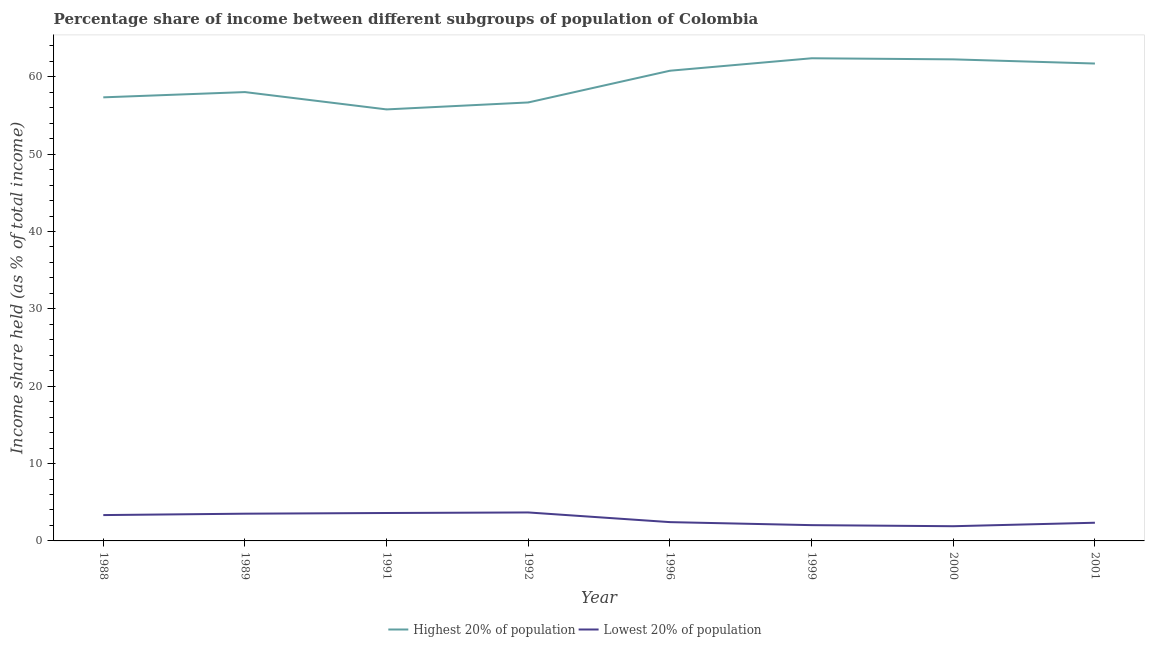How many different coloured lines are there?
Your answer should be compact. 2. Does the line corresponding to income share held by highest 20% of the population intersect with the line corresponding to income share held by lowest 20% of the population?
Ensure brevity in your answer.  No. What is the income share held by lowest 20% of the population in 1992?
Offer a very short reply. 3.68. Across all years, what is the maximum income share held by lowest 20% of the population?
Ensure brevity in your answer.  3.68. Across all years, what is the minimum income share held by highest 20% of the population?
Keep it short and to the point. 55.78. In which year was the income share held by highest 20% of the population minimum?
Provide a short and direct response. 1991. What is the total income share held by lowest 20% of the population in the graph?
Your answer should be very brief. 22.87. What is the difference between the income share held by highest 20% of the population in 1992 and that in 2001?
Your answer should be very brief. -5.03. What is the difference between the income share held by lowest 20% of the population in 2001 and the income share held by highest 20% of the population in 2000?
Offer a terse response. -59.9. What is the average income share held by highest 20% of the population per year?
Ensure brevity in your answer.  59.37. In the year 1992, what is the difference between the income share held by lowest 20% of the population and income share held by highest 20% of the population?
Make the answer very short. -53. In how many years, is the income share held by lowest 20% of the population greater than 18 %?
Your response must be concise. 0. What is the ratio of the income share held by highest 20% of the population in 1988 to that in 2000?
Your response must be concise. 0.92. Is the income share held by lowest 20% of the population in 1991 less than that in 2001?
Keep it short and to the point. No. Is the difference between the income share held by lowest 20% of the population in 1992 and 1996 greater than the difference between the income share held by highest 20% of the population in 1992 and 1996?
Your response must be concise. Yes. What is the difference between the highest and the second highest income share held by highest 20% of the population?
Your answer should be very brief. 0.14. What is the difference between the highest and the lowest income share held by lowest 20% of the population?
Ensure brevity in your answer.  1.78. In how many years, is the income share held by lowest 20% of the population greater than the average income share held by lowest 20% of the population taken over all years?
Make the answer very short. 4. Is the sum of the income share held by highest 20% of the population in 1989 and 1992 greater than the maximum income share held by lowest 20% of the population across all years?
Your answer should be very brief. Yes. How many lines are there?
Your response must be concise. 2. Are the values on the major ticks of Y-axis written in scientific E-notation?
Make the answer very short. No. Does the graph contain grids?
Your response must be concise. No. How many legend labels are there?
Give a very brief answer. 2. How are the legend labels stacked?
Ensure brevity in your answer.  Horizontal. What is the title of the graph?
Give a very brief answer. Percentage share of income between different subgroups of population of Colombia. Does "Investment in Telecom" appear as one of the legend labels in the graph?
Offer a terse response. No. What is the label or title of the X-axis?
Make the answer very short. Year. What is the label or title of the Y-axis?
Keep it short and to the point. Income share held (as % of total income). What is the Income share held (as % of total income) in Highest 20% of population in 1988?
Your answer should be very brief. 57.34. What is the Income share held (as % of total income) of Lowest 20% of population in 1988?
Offer a very short reply. 3.34. What is the Income share held (as % of total income) in Highest 20% of population in 1989?
Give a very brief answer. 58.02. What is the Income share held (as % of total income) in Lowest 20% of population in 1989?
Give a very brief answer. 3.52. What is the Income share held (as % of total income) in Highest 20% of population in 1991?
Offer a very short reply. 55.78. What is the Income share held (as % of total income) of Lowest 20% of population in 1991?
Your answer should be very brief. 3.61. What is the Income share held (as % of total income) in Highest 20% of population in 1992?
Your answer should be compact. 56.68. What is the Income share held (as % of total income) in Lowest 20% of population in 1992?
Your response must be concise. 3.68. What is the Income share held (as % of total income) of Highest 20% of population in 1996?
Offer a terse response. 60.78. What is the Income share held (as % of total income) in Lowest 20% of population in 1996?
Offer a very short reply. 2.43. What is the Income share held (as % of total income) in Highest 20% of population in 1999?
Your answer should be compact. 62.39. What is the Income share held (as % of total income) of Lowest 20% of population in 1999?
Your response must be concise. 2.04. What is the Income share held (as % of total income) in Highest 20% of population in 2000?
Provide a succinct answer. 62.25. What is the Income share held (as % of total income) in Highest 20% of population in 2001?
Your response must be concise. 61.71. What is the Income share held (as % of total income) in Lowest 20% of population in 2001?
Your response must be concise. 2.35. Across all years, what is the maximum Income share held (as % of total income) in Highest 20% of population?
Give a very brief answer. 62.39. Across all years, what is the maximum Income share held (as % of total income) of Lowest 20% of population?
Provide a succinct answer. 3.68. Across all years, what is the minimum Income share held (as % of total income) in Highest 20% of population?
Ensure brevity in your answer.  55.78. Across all years, what is the minimum Income share held (as % of total income) in Lowest 20% of population?
Offer a terse response. 1.9. What is the total Income share held (as % of total income) of Highest 20% of population in the graph?
Provide a succinct answer. 474.95. What is the total Income share held (as % of total income) of Lowest 20% of population in the graph?
Keep it short and to the point. 22.87. What is the difference between the Income share held (as % of total income) of Highest 20% of population in 1988 and that in 1989?
Make the answer very short. -0.68. What is the difference between the Income share held (as % of total income) in Lowest 20% of population in 1988 and that in 1989?
Offer a terse response. -0.18. What is the difference between the Income share held (as % of total income) of Highest 20% of population in 1988 and that in 1991?
Your response must be concise. 1.56. What is the difference between the Income share held (as % of total income) in Lowest 20% of population in 1988 and that in 1991?
Make the answer very short. -0.27. What is the difference between the Income share held (as % of total income) in Highest 20% of population in 1988 and that in 1992?
Make the answer very short. 0.66. What is the difference between the Income share held (as % of total income) of Lowest 20% of population in 1988 and that in 1992?
Provide a short and direct response. -0.34. What is the difference between the Income share held (as % of total income) of Highest 20% of population in 1988 and that in 1996?
Provide a short and direct response. -3.44. What is the difference between the Income share held (as % of total income) of Lowest 20% of population in 1988 and that in 1996?
Your answer should be very brief. 0.91. What is the difference between the Income share held (as % of total income) in Highest 20% of population in 1988 and that in 1999?
Give a very brief answer. -5.05. What is the difference between the Income share held (as % of total income) in Lowest 20% of population in 1988 and that in 1999?
Keep it short and to the point. 1.3. What is the difference between the Income share held (as % of total income) in Highest 20% of population in 1988 and that in 2000?
Offer a terse response. -4.91. What is the difference between the Income share held (as % of total income) of Lowest 20% of population in 1988 and that in 2000?
Your response must be concise. 1.44. What is the difference between the Income share held (as % of total income) of Highest 20% of population in 1988 and that in 2001?
Provide a succinct answer. -4.37. What is the difference between the Income share held (as % of total income) in Lowest 20% of population in 1988 and that in 2001?
Offer a terse response. 0.99. What is the difference between the Income share held (as % of total income) in Highest 20% of population in 1989 and that in 1991?
Offer a terse response. 2.24. What is the difference between the Income share held (as % of total income) in Lowest 20% of population in 1989 and that in 1991?
Your response must be concise. -0.09. What is the difference between the Income share held (as % of total income) of Highest 20% of population in 1989 and that in 1992?
Ensure brevity in your answer.  1.34. What is the difference between the Income share held (as % of total income) in Lowest 20% of population in 1989 and that in 1992?
Your answer should be compact. -0.16. What is the difference between the Income share held (as % of total income) of Highest 20% of population in 1989 and that in 1996?
Provide a short and direct response. -2.76. What is the difference between the Income share held (as % of total income) of Lowest 20% of population in 1989 and that in 1996?
Your answer should be compact. 1.09. What is the difference between the Income share held (as % of total income) in Highest 20% of population in 1989 and that in 1999?
Your answer should be compact. -4.37. What is the difference between the Income share held (as % of total income) in Lowest 20% of population in 1989 and that in 1999?
Provide a succinct answer. 1.48. What is the difference between the Income share held (as % of total income) of Highest 20% of population in 1989 and that in 2000?
Ensure brevity in your answer.  -4.23. What is the difference between the Income share held (as % of total income) of Lowest 20% of population in 1989 and that in 2000?
Ensure brevity in your answer.  1.62. What is the difference between the Income share held (as % of total income) in Highest 20% of population in 1989 and that in 2001?
Offer a very short reply. -3.69. What is the difference between the Income share held (as % of total income) of Lowest 20% of population in 1989 and that in 2001?
Provide a succinct answer. 1.17. What is the difference between the Income share held (as % of total income) of Lowest 20% of population in 1991 and that in 1992?
Give a very brief answer. -0.07. What is the difference between the Income share held (as % of total income) in Lowest 20% of population in 1991 and that in 1996?
Ensure brevity in your answer.  1.18. What is the difference between the Income share held (as % of total income) of Highest 20% of population in 1991 and that in 1999?
Offer a very short reply. -6.61. What is the difference between the Income share held (as % of total income) of Lowest 20% of population in 1991 and that in 1999?
Your answer should be very brief. 1.57. What is the difference between the Income share held (as % of total income) in Highest 20% of population in 1991 and that in 2000?
Make the answer very short. -6.47. What is the difference between the Income share held (as % of total income) of Lowest 20% of population in 1991 and that in 2000?
Your answer should be compact. 1.71. What is the difference between the Income share held (as % of total income) in Highest 20% of population in 1991 and that in 2001?
Your answer should be compact. -5.93. What is the difference between the Income share held (as % of total income) of Lowest 20% of population in 1991 and that in 2001?
Your answer should be very brief. 1.26. What is the difference between the Income share held (as % of total income) in Highest 20% of population in 1992 and that in 1996?
Ensure brevity in your answer.  -4.1. What is the difference between the Income share held (as % of total income) in Highest 20% of population in 1992 and that in 1999?
Your answer should be compact. -5.71. What is the difference between the Income share held (as % of total income) of Lowest 20% of population in 1992 and that in 1999?
Make the answer very short. 1.64. What is the difference between the Income share held (as % of total income) in Highest 20% of population in 1992 and that in 2000?
Make the answer very short. -5.57. What is the difference between the Income share held (as % of total income) of Lowest 20% of population in 1992 and that in 2000?
Your answer should be compact. 1.78. What is the difference between the Income share held (as % of total income) of Highest 20% of population in 1992 and that in 2001?
Ensure brevity in your answer.  -5.03. What is the difference between the Income share held (as % of total income) of Lowest 20% of population in 1992 and that in 2001?
Provide a succinct answer. 1.33. What is the difference between the Income share held (as % of total income) of Highest 20% of population in 1996 and that in 1999?
Give a very brief answer. -1.61. What is the difference between the Income share held (as % of total income) of Lowest 20% of population in 1996 and that in 1999?
Your answer should be very brief. 0.39. What is the difference between the Income share held (as % of total income) of Highest 20% of population in 1996 and that in 2000?
Ensure brevity in your answer.  -1.47. What is the difference between the Income share held (as % of total income) in Lowest 20% of population in 1996 and that in 2000?
Keep it short and to the point. 0.53. What is the difference between the Income share held (as % of total income) of Highest 20% of population in 1996 and that in 2001?
Offer a terse response. -0.93. What is the difference between the Income share held (as % of total income) in Highest 20% of population in 1999 and that in 2000?
Ensure brevity in your answer.  0.14. What is the difference between the Income share held (as % of total income) of Lowest 20% of population in 1999 and that in 2000?
Give a very brief answer. 0.14. What is the difference between the Income share held (as % of total income) in Highest 20% of population in 1999 and that in 2001?
Your answer should be very brief. 0.68. What is the difference between the Income share held (as % of total income) of Lowest 20% of population in 1999 and that in 2001?
Your response must be concise. -0.31. What is the difference between the Income share held (as % of total income) in Highest 20% of population in 2000 and that in 2001?
Give a very brief answer. 0.54. What is the difference between the Income share held (as % of total income) of Lowest 20% of population in 2000 and that in 2001?
Your response must be concise. -0.45. What is the difference between the Income share held (as % of total income) of Highest 20% of population in 1988 and the Income share held (as % of total income) of Lowest 20% of population in 1989?
Ensure brevity in your answer.  53.82. What is the difference between the Income share held (as % of total income) of Highest 20% of population in 1988 and the Income share held (as % of total income) of Lowest 20% of population in 1991?
Offer a very short reply. 53.73. What is the difference between the Income share held (as % of total income) of Highest 20% of population in 1988 and the Income share held (as % of total income) of Lowest 20% of population in 1992?
Make the answer very short. 53.66. What is the difference between the Income share held (as % of total income) in Highest 20% of population in 1988 and the Income share held (as % of total income) in Lowest 20% of population in 1996?
Keep it short and to the point. 54.91. What is the difference between the Income share held (as % of total income) of Highest 20% of population in 1988 and the Income share held (as % of total income) of Lowest 20% of population in 1999?
Provide a succinct answer. 55.3. What is the difference between the Income share held (as % of total income) of Highest 20% of population in 1988 and the Income share held (as % of total income) of Lowest 20% of population in 2000?
Your response must be concise. 55.44. What is the difference between the Income share held (as % of total income) in Highest 20% of population in 1988 and the Income share held (as % of total income) in Lowest 20% of population in 2001?
Provide a short and direct response. 54.99. What is the difference between the Income share held (as % of total income) in Highest 20% of population in 1989 and the Income share held (as % of total income) in Lowest 20% of population in 1991?
Offer a very short reply. 54.41. What is the difference between the Income share held (as % of total income) in Highest 20% of population in 1989 and the Income share held (as % of total income) in Lowest 20% of population in 1992?
Your response must be concise. 54.34. What is the difference between the Income share held (as % of total income) in Highest 20% of population in 1989 and the Income share held (as % of total income) in Lowest 20% of population in 1996?
Your answer should be very brief. 55.59. What is the difference between the Income share held (as % of total income) of Highest 20% of population in 1989 and the Income share held (as % of total income) of Lowest 20% of population in 1999?
Your response must be concise. 55.98. What is the difference between the Income share held (as % of total income) of Highest 20% of population in 1989 and the Income share held (as % of total income) of Lowest 20% of population in 2000?
Ensure brevity in your answer.  56.12. What is the difference between the Income share held (as % of total income) in Highest 20% of population in 1989 and the Income share held (as % of total income) in Lowest 20% of population in 2001?
Your answer should be compact. 55.67. What is the difference between the Income share held (as % of total income) of Highest 20% of population in 1991 and the Income share held (as % of total income) of Lowest 20% of population in 1992?
Give a very brief answer. 52.1. What is the difference between the Income share held (as % of total income) of Highest 20% of population in 1991 and the Income share held (as % of total income) of Lowest 20% of population in 1996?
Give a very brief answer. 53.35. What is the difference between the Income share held (as % of total income) in Highest 20% of population in 1991 and the Income share held (as % of total income) in Lowest 20% of population in 1999?
Keep it short and to the point. 53.74. What is the difference between the Income share held (as % of total income) of Highest 20% of population in 1991 and the Income share held (as % of total income) of Lowest 20% of population in 2000?
Your answer should be compact. 53.88. What is the difference between the Income share held (as % of total income) in Highest 20% of population in 1991 and the Income share held (as % of total income) in Lowest 20% of population in 2001?
Provide a succinct answer. 53.43. What is the difference between the Income share held (as % of total income) of Highest 20% of population in 1992 and the Income share held (as % of total income) of Lowest 20% of population in 1996?
Your answer should be compact. 54.25. What is the difference between the Income share held (as % of total income) of Highest 20% of population in 1992 and the Income share held (as % of total income) of Lowest 20% of population in 1999?
Your response must be concise. 54.64. What is the difference between the Income share held (as % of total income) of Highest 20% of population in 1992 and the Income share held (as % of total income) of Lowest 20% of population in 2000?
Your response must be concise. 54.78. What is the difference between the Income share held (as % of total income) in Highest 20% of population in 1992 and the Income share held (as % of total income) in Lowest 20% of population in 2001?
Your answer should be very brief. 54.33. What is the difference between the Income share held (as % of total income) in Highest 20% of population in 1996 and the Income share held (as % of total income) in Lowest 20% of population in 1999?
Provide a short and direct response. 58.74. What is the difference between the Income share held (as % of total income) in Highest 20% of population in 1996 and the Income share held (as % of total income) in Lowest 20% of population in 2000?
Give a very brief answer. 58.88. What is the difference between the Income share held (as % of total income) of Highest 20% of population in 1996 and the Income share held (as % of total income) of Lowest 20% of population in 2001?
Provide a succinct answer. 58.43. What is the difference between the Income share held (as % of total income) of Highest 20% of population in 1999 and the Income share held (as % of total income) of Lowest 20% of population in 2000?
Offer a terse response. 60.49. What is the difference between the Income share held (as % of total income) in Highest 20% of population in 1999 and the Income share held (as % of total income) in Lowest 20% of population in 2001?
Offer a very short reply. 60.04. What is the difference between the Income share held (as % of total income) in Highest 20% of population in 2000 and the Income share held (as % of total income) in Lowest 20% of population in 2001?
Keep it short and to the point. 59.9. What is the average Income share held (as % of total income) of Highest 20% of population per year?
Your response must be concise. 59.37. What is the average Income share held (as % of total income) of Lowest 20% of population per year?
Ensure brevity in your answer.  2.86. In the year 1989, what is the difference between the Income share held (as % of total income) in Highest 20% of population and Income share held (as % of total income) in Lowest 20% of population?
Give a very brief answer. 54.5. In the year 1991, what is the difference between the Income share held (as % of total income) in Highest 20% of population and Income share held (as % of total income) in Lowest 20% of population?
Give a very brief answer. 52.17. In the year 1992, what is the difference between the Income share held (as % of total income) in Highest 20% of population and Income share held (as % of total income) in Lowest 20% of population?
Provide a short and direct response. 53. In the year 1996, what is the difference between the Income share held (as % of total income) in Highest 20% of population and Income share held (as % of total income) in Lowest 20% of population?
Your response must be concise. 58.35. In the year 1999, what is the difference between the Income share held (as % of total income) of Highest 20% of population and Income share held (as % of total income) of Lowest 20% of population?
Your answer should be compact. 60.35. In the year 2000, what is the difference between the Income share held (as % of total income) of Highest 20% of population and Income share held (as % of total income) of Lowest 20% of population?
Your answer should be compact. 60.35. In the year 2001, what is the difference between the Income share held (as % of total income) in Highest 20% of population and Income share held (as % of total income) in Lowest 20% of population?
Provide a succinct answer. 59.36. What is the ratio of the Income share held (as % of total income) of Highest 20% of population in 1988 to that in 1989?
Your answer should be very brief. 0.99. What is the ratio of the Income share held (as % of total income) in Lowest 20% of population in 1988 to that in 1989?
Make the answer very short. 0.95. What is the ratio of the Income share held (as % of total income) of Highest 20% of population in 1988 to that in 1991?
Provide a succinct answer. 1.03. What is the ratio of the Income share held (as % of total income) in Lowest 20% of population in 1988 to that in 1991?
Your answer should be compact. 0.93. What is the ratio of the Income share held (as % of total income) in Highest 20% of population in 1988 to that in 1992?
Offer a very short reply. 1.01. What is the ratio of the Income share held (as % of total income) in Lowest 20% of population in 1988 to that in 1992?
Your response must be concise. 0.91. What is the ratio of the Income share held (as % of total income) of Highest 20% of population in 1988 to that in 1996?
Offer a terse response. 0.94. What is the ratio of the Income share held (as % of total income) of Lowest 20% of population in 1988 to that in 1996?
Give a very brief answer. 1.37. What is the ratio of the Income share held (as % of total income) of Highest 20% of population in 1988 to that in 1999?
Your answer should be compact. 0.92. What is the ratio of the Income share held (as % of total income) of Lowest 20% of population in 1988 to that in 1999?
Give a very brief answer. 1.64. What is the ratio of the Income share held (as % of total income) in Highest 20% of population in 1988 to that in 2000?
Keep it short and to the point. 0.92. What is the ratio of the Income share held (as % of total income) in Lowest 20% of population in 1988 to that in 2000?
Ensure brevity in your answer.  1.76. What is the ratio of the Income share held (as % of total income) of Highest 20% of population in 1988 to that in 2001?
Offer a terse response. 0.93. What is the ratio of the Income share held (as % of total income) in Lowest 20% of population in 1988 to that in 2001?
Make the answer very short. 1.42. What is the ratio of the Income share held (as % of total income) in Highest 20% of population in 1989 to that in 1991?
Make the answer very short. 1.04. What is the ratio of the Income share held (as % of total income) of Lowest 20% of population in 1989 to that in 1991?
Give a very brief answer. 0.98. What is the ratio of the Income share held (as % of total income) in Highest 20% of population in 1989 to that in 1992?
Your answer should be compact. 1.02. What is the ratio of the Income share held (as % of total income) in Lowest 20% of population in 1989 to that in 1992?
Offer a terse response. 0.96. What is the ratio of the Income share held (as % of total income) of Highest 20% of population in 1989 to that in 1996?
Ensure brevity in your answer.  0.95. What is the ratio of the Income share held (as % of total income) of Lowest 20% of population in 1989 to that in 1996?
Give a very brief answer. 1.45. What is the ratio of the Income share held (as % of total income) of Highest 20% of population in 1989 to that in 1999?
Provide a succinct answer. 0.93. What is the ratio of the Income share held (as % of total income) in Lowest 20% of population in 1989 to that in 1999?
Make the answer very short. 1.73. What is the ratio of the Income share held (as % of total income) in Highest 20% of population in 1989 to that in 2000?
Provide a short and direct response. 0.93. What is the ratio of the Income share held (as % of total income) in Lowest 20% of population in 1989 to that in 2000?
Your answer should be very brief. 1.85. What is the ratio of the Income share held (as % of total income) of Highest 20% of population in 1989 to that in 2001?
Your response must be concise. 0.94. What is the ratio of the Income share held (as % of total income) in Lowest 20% of population in 1989 to that in 2001?
Ensure brevity in your answer.  1.5. What is the ratio of the Income share held (as % of total income) of Highest 20% of population in 1991 to that in 1992?
Your response must be concise. 0.98. What is the ratio of the Income share held (as % of total income) of Lowest 20% of population in 1991 to that in 1992?
Offer a very short reply. 0.98. What is the ratio of the Income share held (as % of total income) in Highest 20% of population in 1991 to that in 1996?
Your answer should be very brief. 0.92. What is the ratio of the Income share held (as % of total income) in Lowest 20% of population in 1991 to that in 1996?
Offer a terse response. 1.49. What is the ratio of the Income share held (as % of total income) in Highest 20% of population in 1991 to that in 1999?
Provide a succinct answer. 0.89. What is the ratio of the Income share held (as % of total income) in Lowest 20% of population in 1991 to that in 1999?
Make the answer very short. 1.77. What is the ratio of the Income share held (as % of total income) of Highest 20% of population in 1991 to that in 2000?
Give a very brief answer. 0.9. What is the ratio of the Income share held (as % of total income) in Lowest 20% of population in 1991 to that in 2000?
Provide a short and direct response. 1.9. What is the ratio of the Income share held (as % of total income) of Highest 20% of population in 1991 to that in 2001?
Provide a succinct answer. 0.9. What is the ratio of the Income share held (as % of total income) in Lowest 20% of population in 1991 to that in 2001?
Keep it short and to the point. 1.54. What is the ratio of the Income share held (as % of total income) in Highest 20% of population in 1992 to that in 1996?
Your answer should be very brief. 0.93. What is the ratio of the Income share held (as % of total income) in Lowest 20% of population in 1992 to that in 1996?
Provide a short and direct response. 1.51. What is the ratio of the Income share held (as % of total income) in Highest 20% of population in 1992 to that in 1999?
Provide a succinct answer. 0.91. What is the ratio of the Income share held (as % of total income) in Lowest 20% of population in 1992 to that in 1999?
Make the answer very short. 1.8. What is the ratio of the Income share held (as % of total income) in Highest 20% of population in 1992 to that in 2000?
Provide a short and direct response. 0.91. What is the ratio of the Income share held (as % of total income) of Lowest 20% of population in 1992 to that in 2000?
Provide a succinct answer. 1.94. What is the ratio of the Income share held (as % of total income) in Highest 20% of population in 1992 to that in 2001?
Your response must be concise. 0.92. What is the ratio of the Income share held (as % of total income) in Lowest 20% of population in 1992 to that in 2001?
Offer a very short reply. 1.57. What is the ratio of the Income share held (as % of total income) of Highest 20% of population in 1996 to that in 1999?
Provide a succinct answer. 0.97. What is the ratio of the Income share held (as % of total income) in Lowest 20% of population in 1996 to that in 1999?
Keep it short and to the point. 1.19. What is the ratio of the Income share held (as % of total income) of Highest 20% of population in 1996 to that in 2000?
Your answer should be very brief. 0.98. What is the ratio of the Income share held (as % of total income) in Lowest 20% of population in 1996 to that in 2000?
Keep it short and to the point. 1.28. What is the ratio of the Income share held (as % of total income) of Highest 20% of population in 1996 to that in 2001?
Ensure brevity in your answer.  0.98. What is the ratio of the Income share held (as % of total income) in Lowest 20% of population in 1996 to that in 2001?
Your answer should be compact. 1.03. What is the ratio of the Income share held (as % of total income) of Lowest 20% of population in 1999 to that in 2000?
Your answer should be compact. 1.07. What is the ratio of the Income share held (as % of total income) in Lowest 20% of population in 1999 to that in 2001?
Your answer should be compact. 0.87. What is the ratio of the Income share held (as % of total income) of Highest 20% of population in 2000 to that in 2001?
Make the answer very short. 1.01. What is the ratio of the Income share held (as % of total income) of Lowest 20% of population in 2000 to that in 2001?
Ensure brevity in your answer.  0.81. What is the difference between the highest and the second highest Income share held (as % of total income) of Highest 20% of population?
Offer a terse response. 0.14. What is the difference between the highest and the second highest Income share held (as % of total income) in Lowest 20% of population?
Provide a succinct answer. 0.07. What is the difference between the highest and the lowest Income share held (as % of total income) of Highest 20% of population?
Ensure brevity in your answer.  6.61. What is the difference between the highest and the lowest Income share held (as % of total income) in Lowest 20% of population?
Your answer should be very brief. 1.78. 